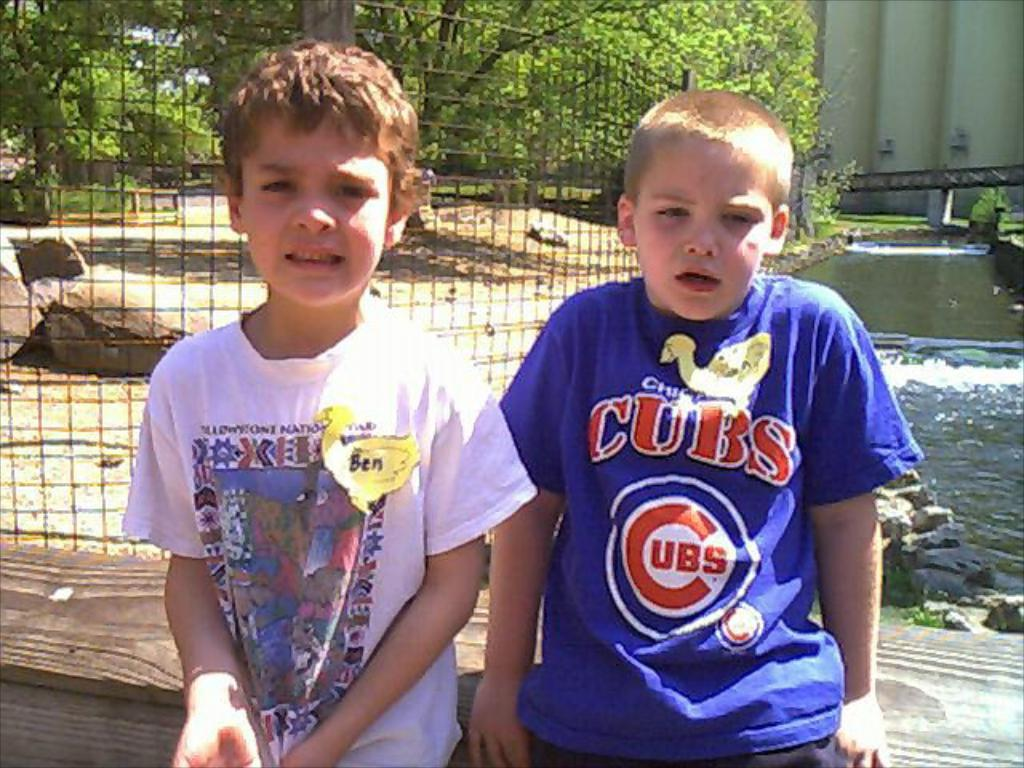<image>
Give a short and clear explanation of the subsequent image. A young boy wearing a Cubs shirt sits on a bench next to another young boy 